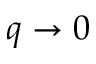<formula> <loc_0><loc_0><loc_500><loc_500>q \to 0</formula> 